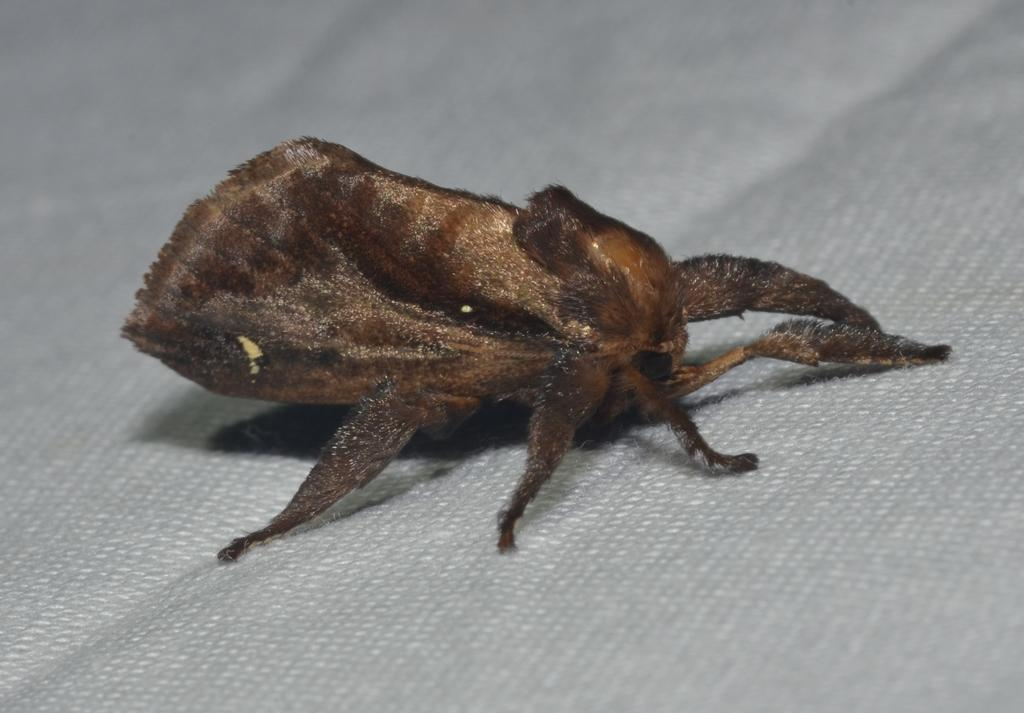What type of creature can be seen in the image? There is an insect in the image. Where is the insect located? The insect is on a cloth. What type of beam is holding up the ceiling in the image? There is no mention of a ceiling or any beams in the image; it only features an insect on a cloth. 